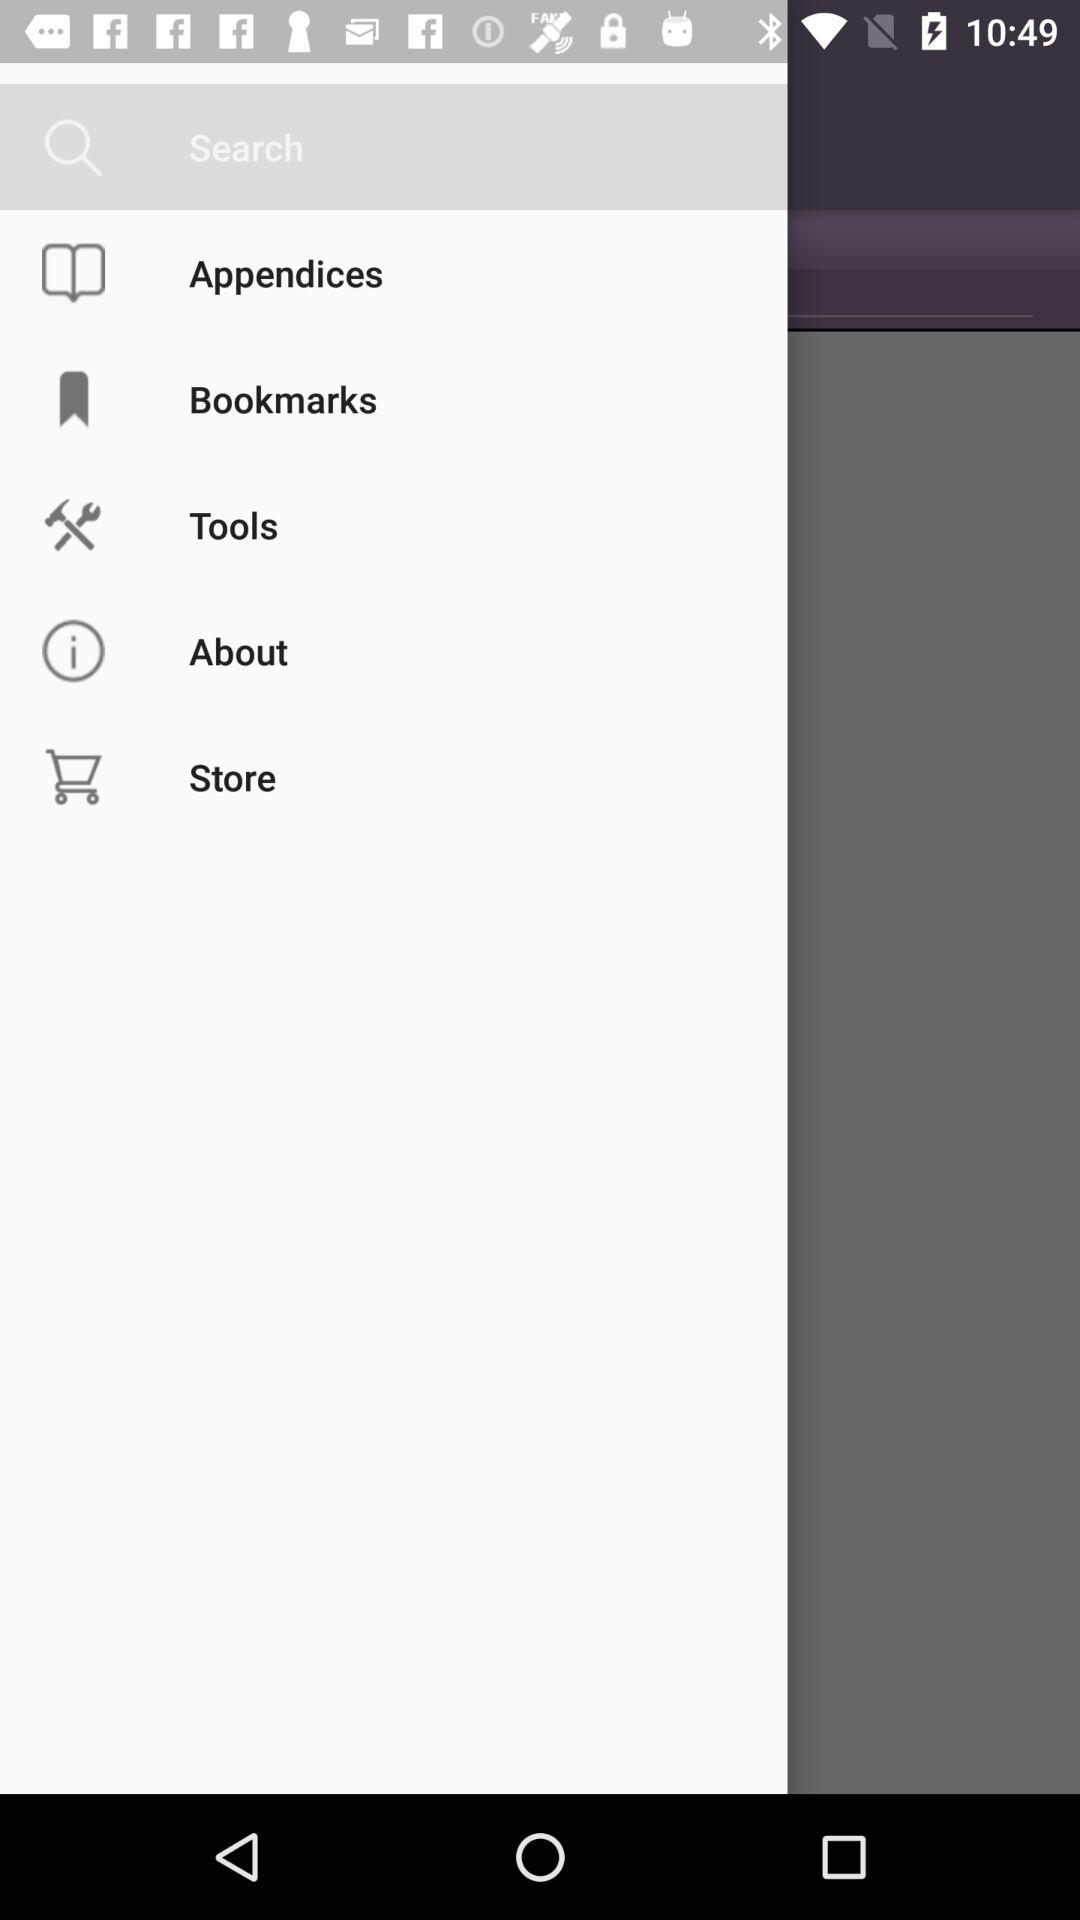How many bookmarks are there?
When the provided information is insufficient, respond with <no answer>. <no answer> 